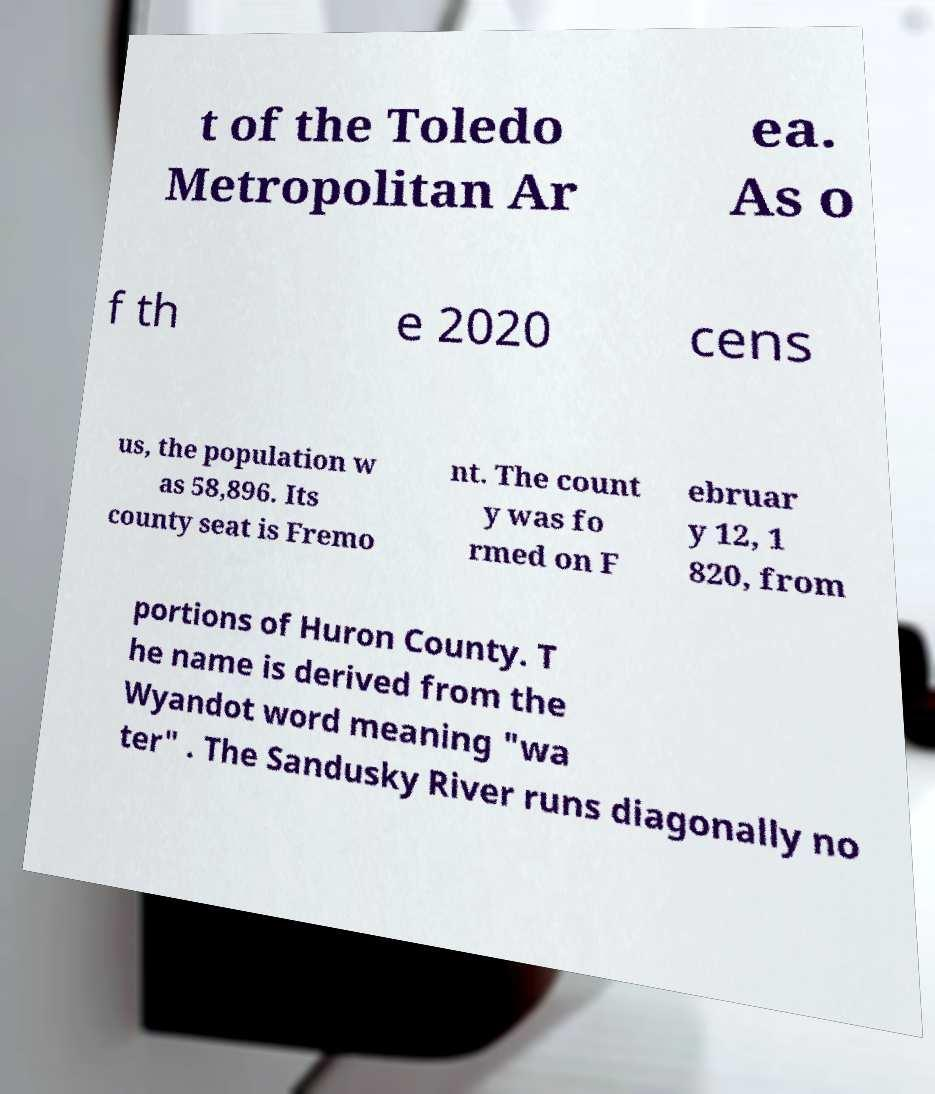I need the written content from this picture converted into text. Can you do that? t of the Toledo Metropolitan Ar ea. As o f th e 2020 cens us, the population w as 58,896. Its county seat is Fremo nt. The count y was fo rmed on F ebruar y 12, 1 820, from portions of Huron County. T he name is derived from the Wyandot word meaning "wa ter" . The Sandusky River runs diagonally no 